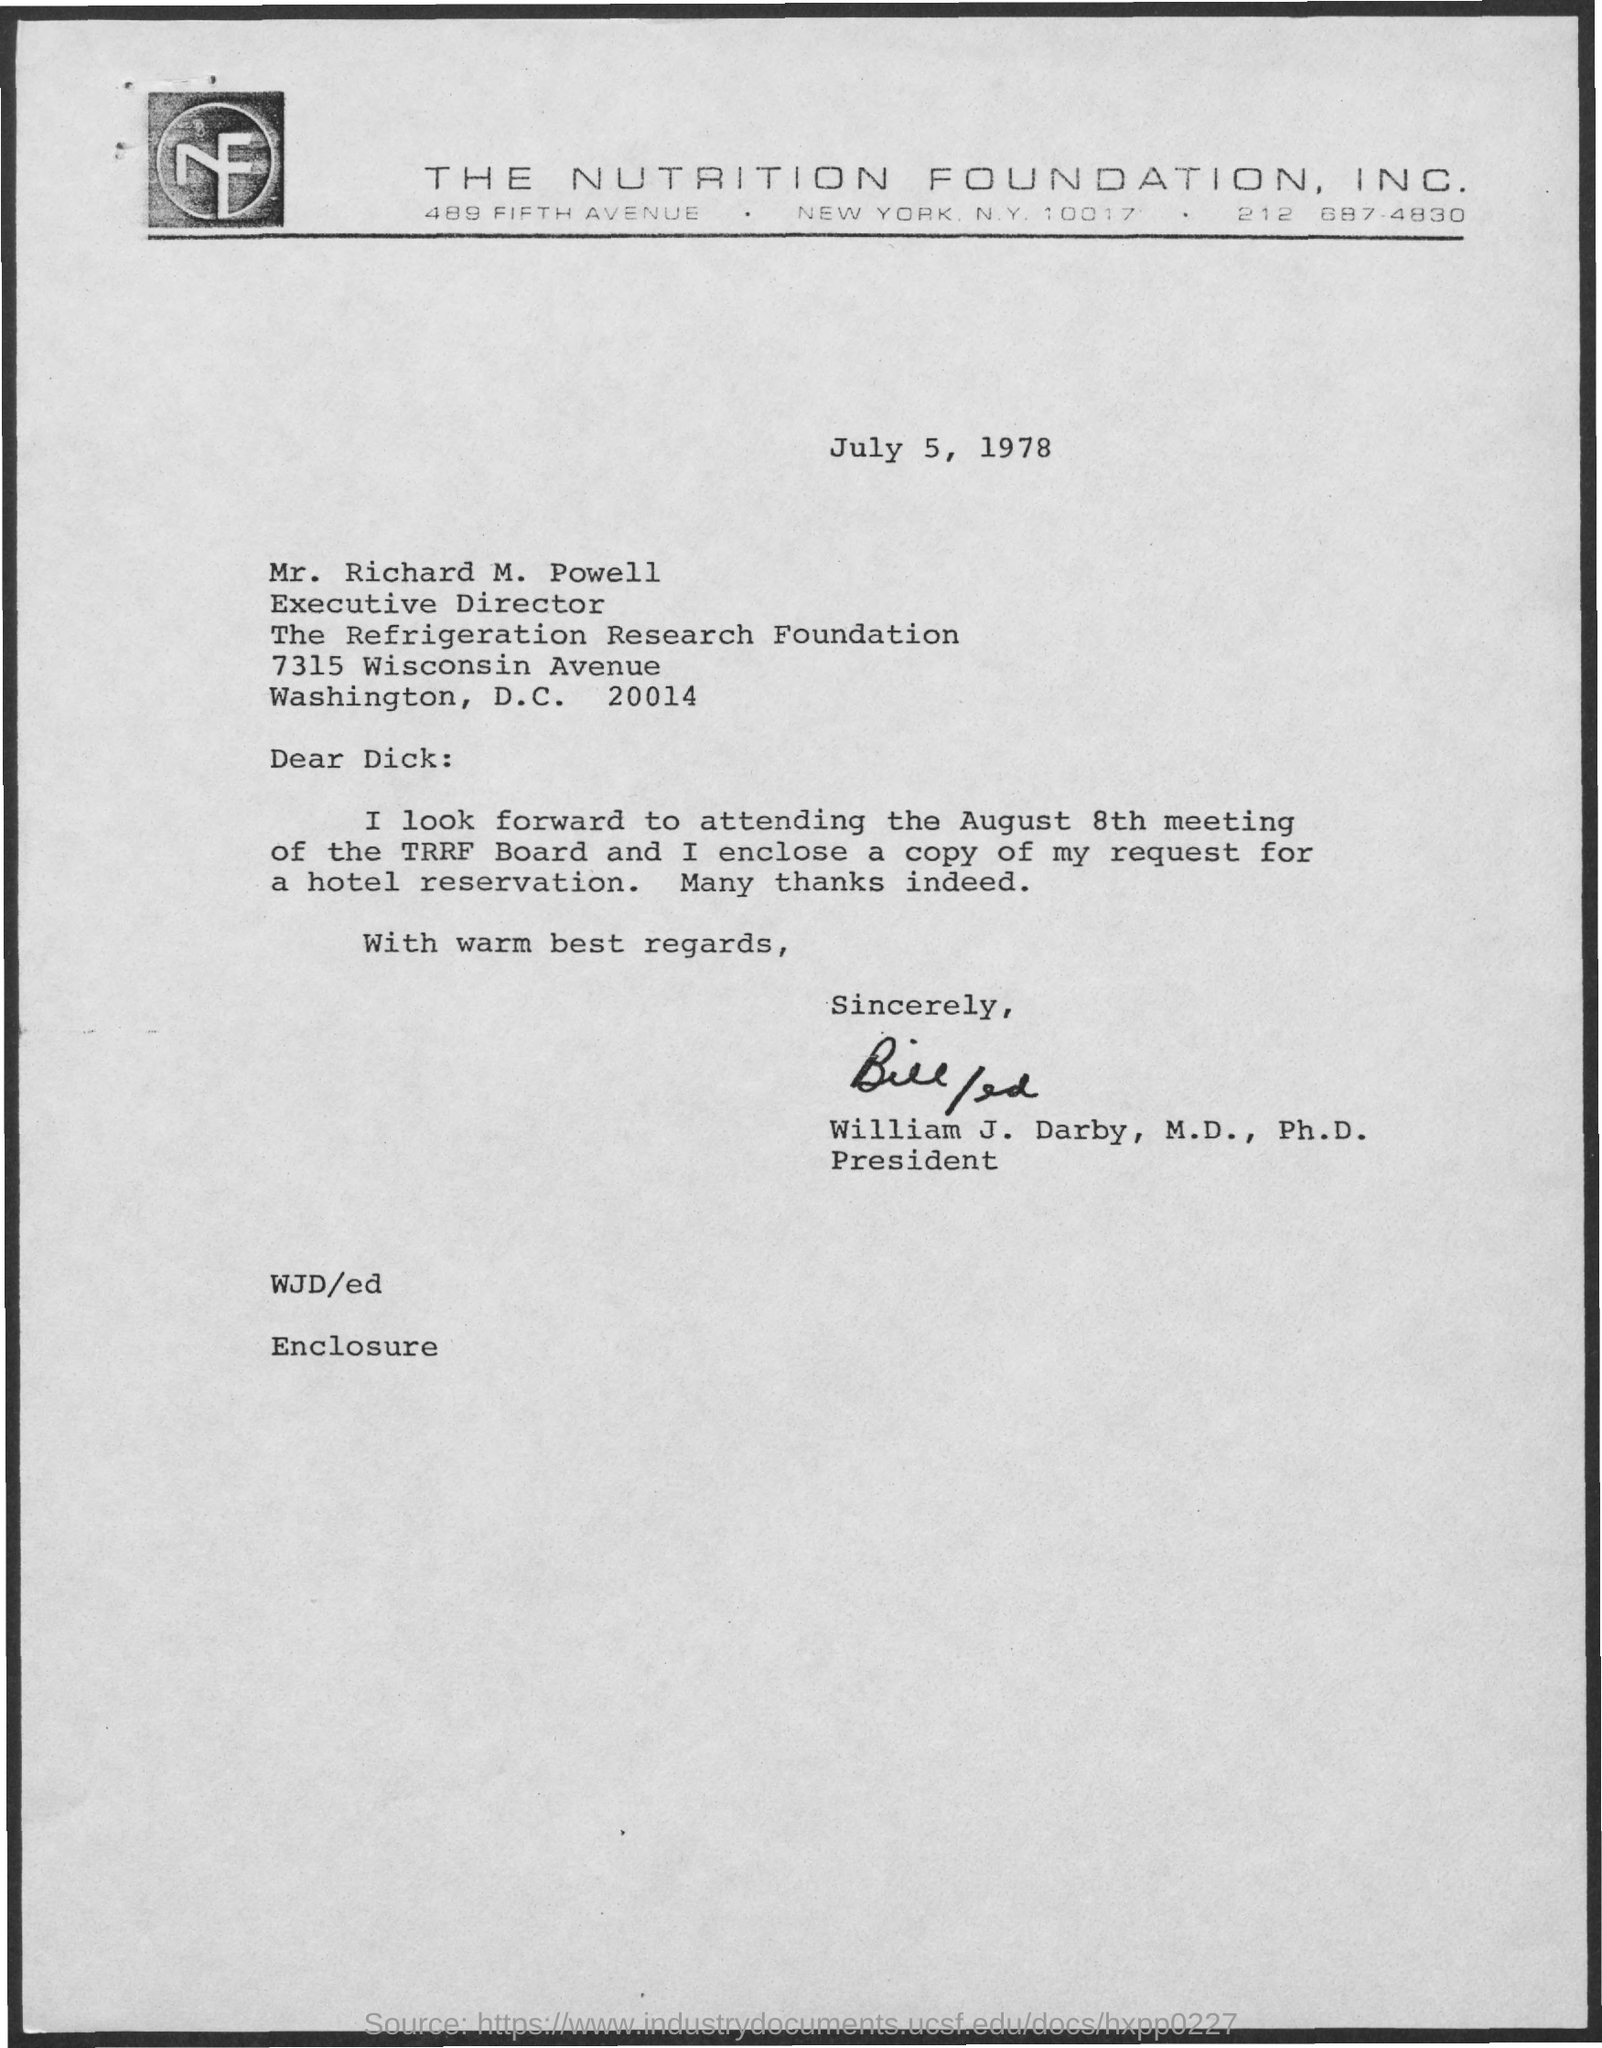What is the date on the document?
Give a very brief answer. July 5, 1978. To Whom is this letter addressed to?
Keep it short and to the point. MR. RICHARD M. POWELL. When is the meeting of the TRRF Board?
Provide a short and direct response. August 8th. Who is this letter from?
Provide a succinct answer. William J. Darby, M.D., Ph.D. 